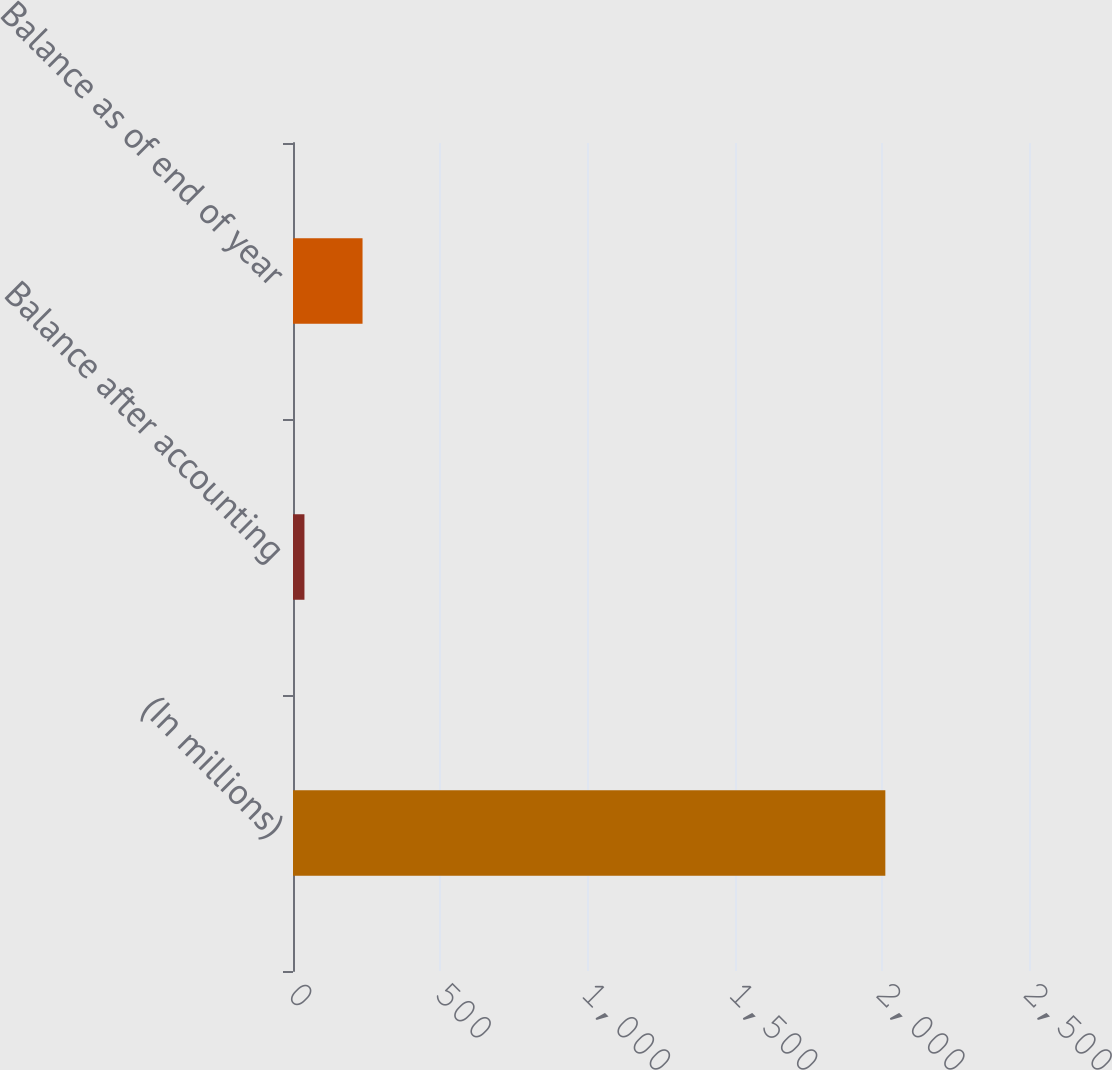<chart> <loc_0><loc_0><loc_500><loc_500><bar_chart><fcel>(In millions)<fcel>Balance after accounting<fcel>Balance as of end of year<nl><fcel>2012<fcel>38.9<fcel>236.21<nl></chart> 